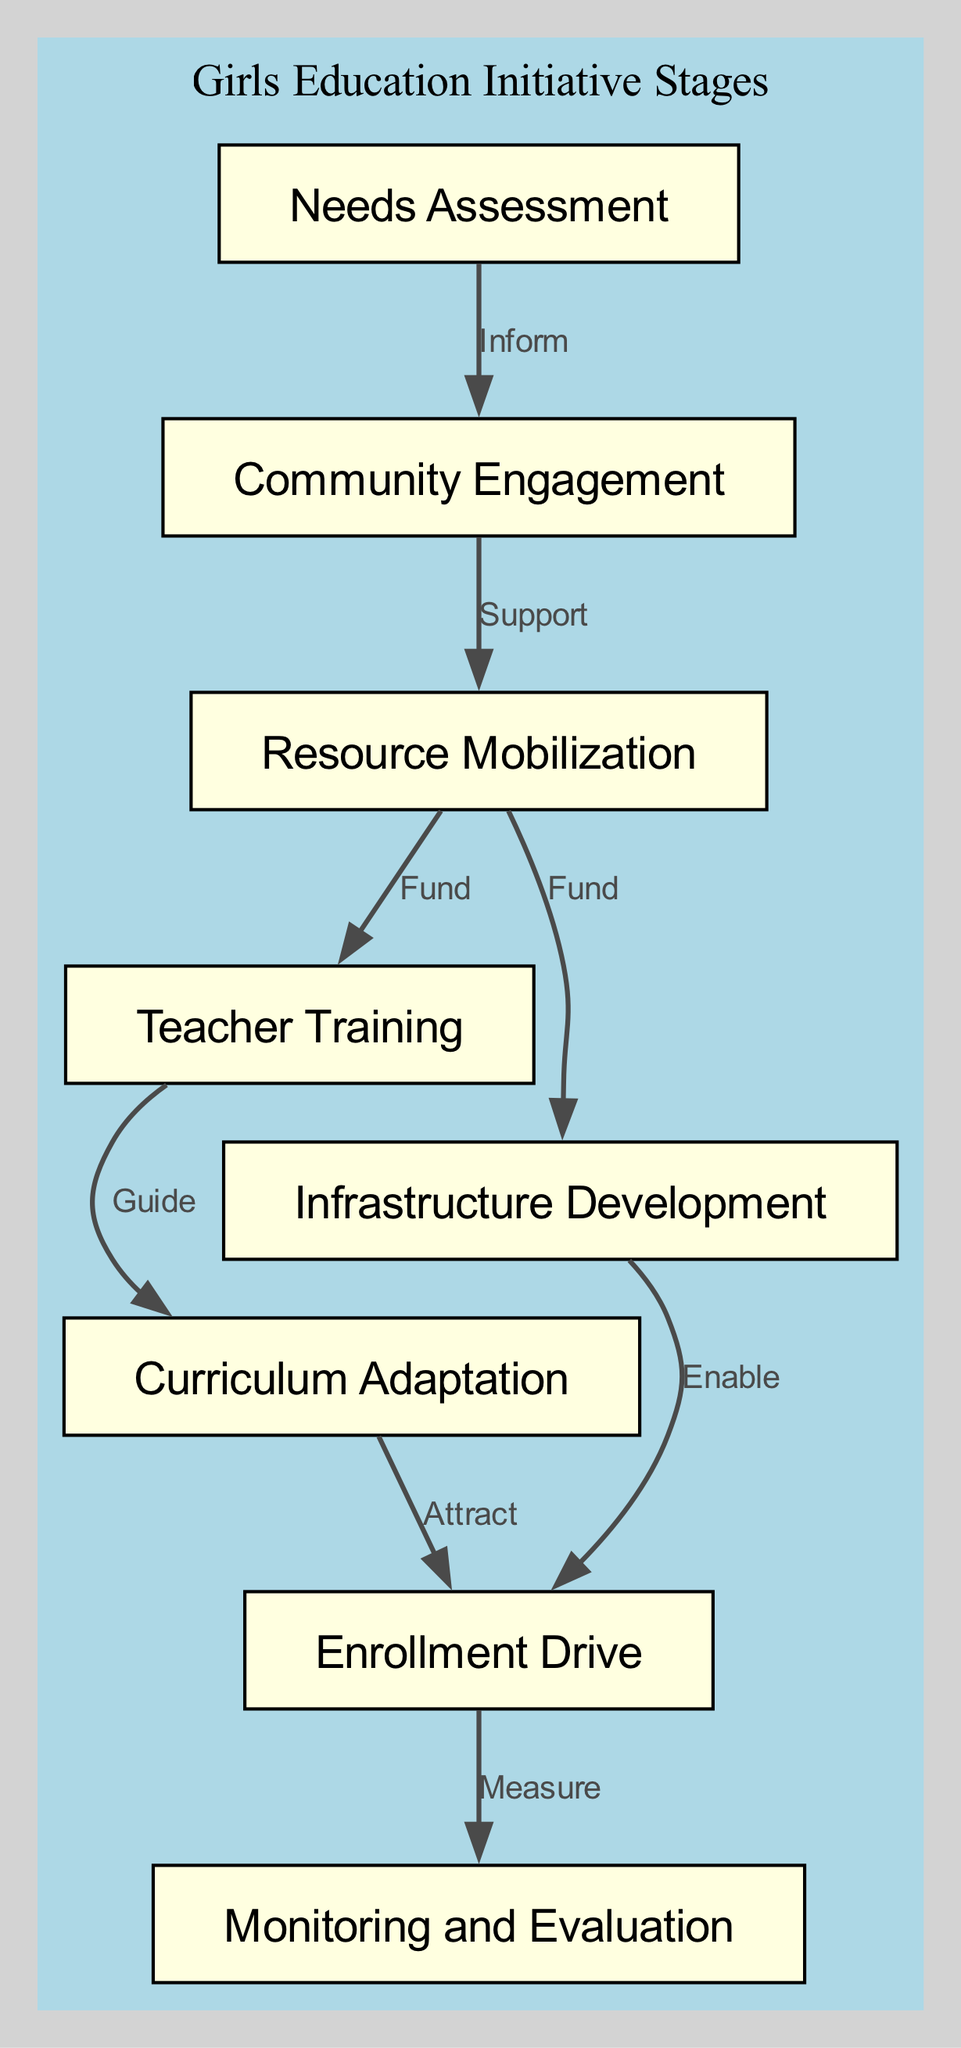What are the first and last stages in the implementation process? The first stage is "Needs Assessment," which is identified as the starting point. The last stage is "Monitoring and Evaluation," as it is the final connection in the diagram.
Answer: Needs Assessment, Monitoring and Evaluation How many blocks are there in total? By counting each distinct block listed in the diagram, we find there are eight unique stages present in the process.
Answer: 8 What label connects "Resource Mobilization" to "Teacher Training"? The diagram shows the connection labeled as "Fund," indicating that resources allocated for mobilization are intended to support teacher training directly.
Answer: Fund Which stage follows "Infrastructure Development"? The diagram indicates that "Infrastructure Development" directly connects to "Enrollment Drive," meaning it is the next stage to occur after that.
Answer: Enrollment Drive What is the relationship between "Curriculum Adaptation" and "Enrollment Drive"? In the diagram, "Curriculum Adaptation" is associated with "Enrollment Drive" through the label "Attract," implying that changes in the curriculum play a role in drawing students to enroll.
Answer: Attract What enables the "Enrollment Drive"? The connection from "Infrastructure Development" to "Enrollment Drive" is labeled "Enable," suggesting that developing infrastructure is a prerequisite for successfully driving enrollment.
Answer: Enable How many connections are there in total? By reviewing all the arrows and their respective labels, we can ascertain that there are eight connections illustrated between various stages in the diagram.
Answer: 8 What is the role of "Teacher Training" in the initiative? "Teacher Training" serves as a guiding force for "Curriculum Adaptation," signifying that the training of educators is essential for adapting the education curriculum effectively.
Answer: Guide What does the "Community Engagement" stage support? The connection from "Community Engagement" to "Resource Mobilization" indicates that this stage is necessary for providing support to mobilize resources effectively for the educational initiative.
Answer: Resource Mobilization 